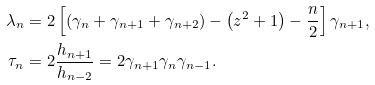<formula> <loc_0><loc_0><loc_500><loc_500>\lambda _ { n } & = 2 \left [ \left ( \gamma _ { n } + \gamma _ { n + 1 } + \gamma _ { n + 2 } \right ) - \left ( z ^ { 2 } + 1 \right ) - \frac { n } { 2 } \right ] \gamma _ { n + 1 } , \\ \tau _ { n } & = 2 \frac { h _ { n + 1 } } { h _ { n - 2 } } = 2 \gamma _ { n + 1 } \gamma _ { n } \gamma _ { n - 1 } .</formula> 